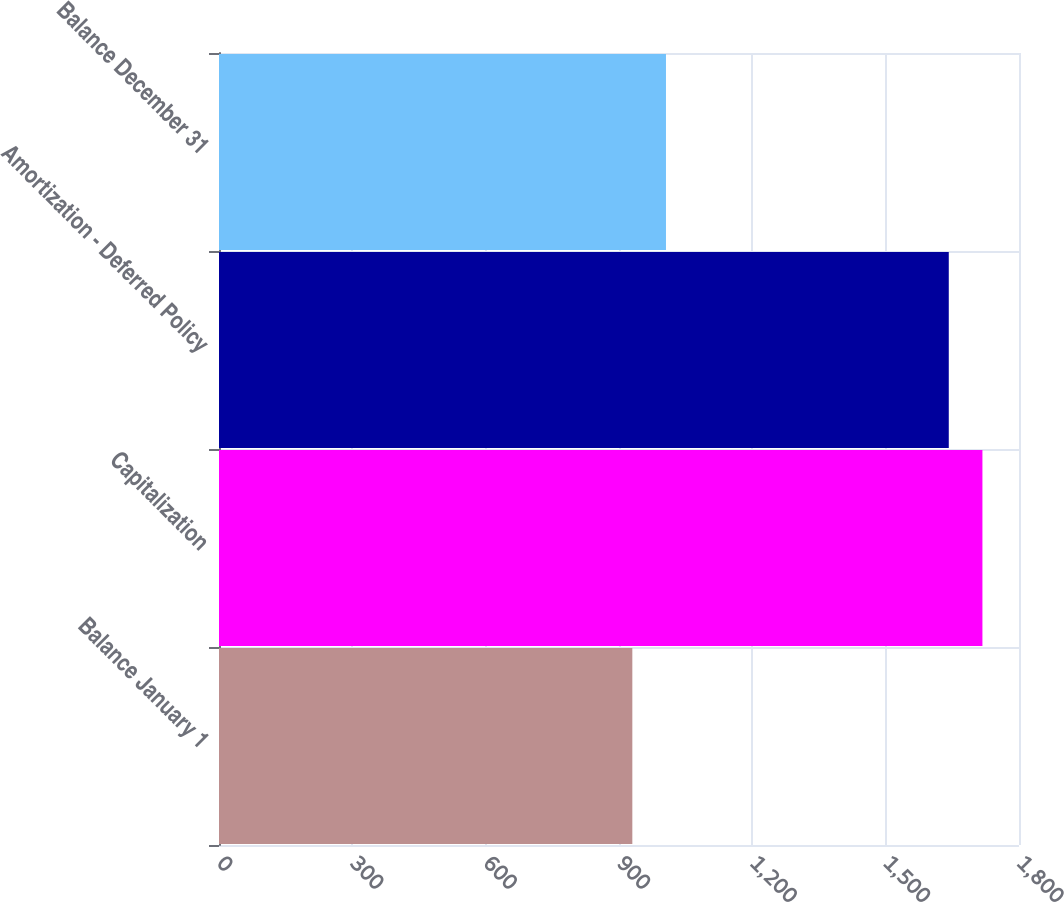Convert chart. <chart><loc_0><loc_0><loc_500><loc_500><bar_chart><fcel>Balance January 1<fcel>Capitalization<fcel>Amortization - Deferred Policy<fcel>Balance December 31<nl><fcel>930<fcel>1717.7<fcel>1642<fcel>1005.7<nl></chart> 